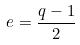Convert formula to latex. <formula><loc_0><loc_0><loc_500><loc_500>e = \frac { q - 1 } { 2 }</formula> 